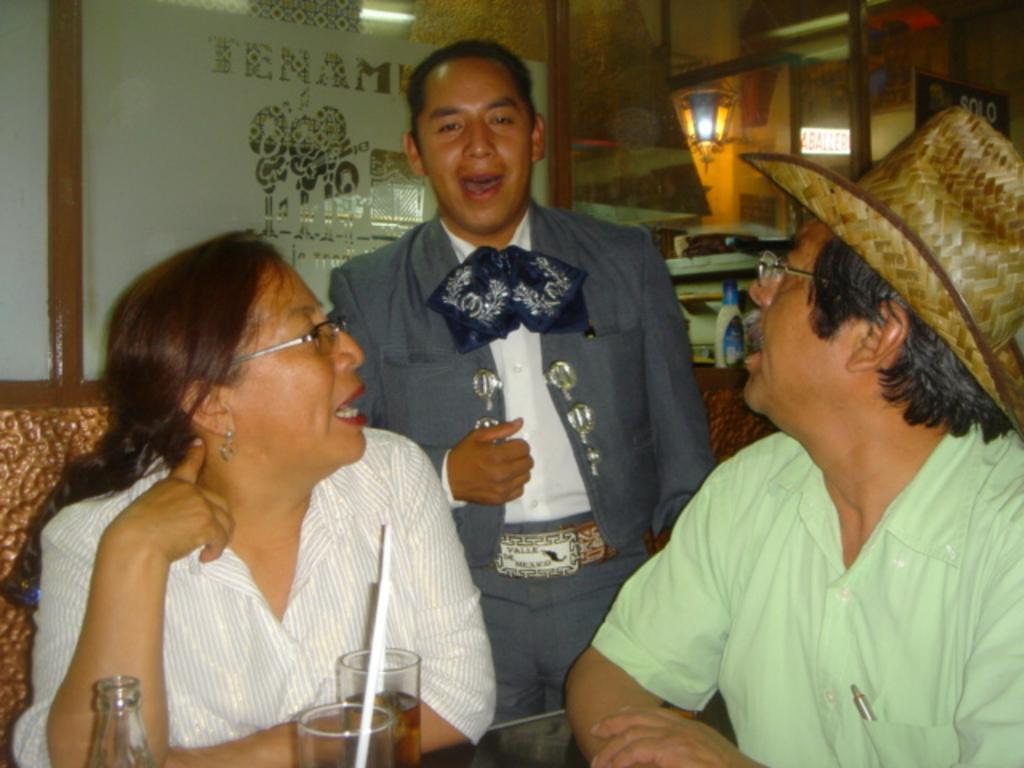How would you summarize this image in a sentence or two? In this picture we can see two men and one woman where one man and woman sitting on chairs and one is standing and they are talking to each other and in front of them on table we have glasses with drinks, straws in it, bottle and in background we can see wall, light, machine, bottle. 